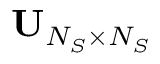Convert formula to latex. <formula><loc_0><loc_0><loc_500><loc_500>{ U } _ { N _ { S } \times N _ { S } }</formula> 